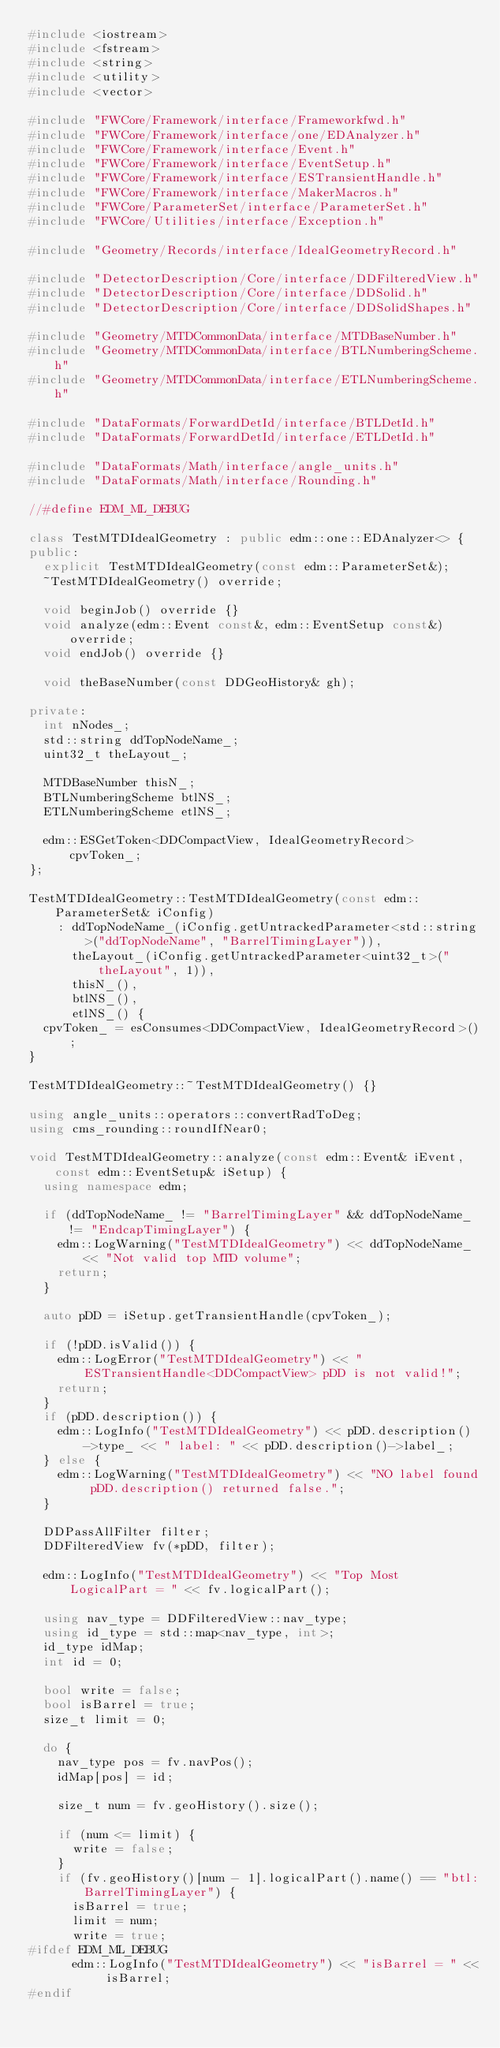<code> <loc_0><loc_0><loc_500><loc_500><_C++_>#include <iostream>
#include <fstream>
#include <string>
#include <utility>
#include <vector>

#include "FWCore/Framework/interface/Frameworkfwd.h"
#include "FWCore/Framework/interface/one/EDAnalyzer.h"
#include "FWCore/Framework/interface/Event.h"
#include "FWCore/Framework/interface/EventSetup.h"
#include "FWCore/Framework/interface/ESTransientHandle.h"
#include "FWCore/Framework/interface/MakerMacros.h"
#include "FWCore/ParameterSet/interface/ParameterSet.h"
#include "FWCore/Utilities/interface/Exception.h"

#include "Geometry/Records/interface/IdealGeometryRecord.h"

#include "DetectorDescription/Core/interface/DDFilteredView.h"
#include "DetectorDescription/Core/interface/DDSolid.h"
#include "DetectorDescription/Core/interface/DDSolidShapes.h"

#include "Geometry/MTDCommonData/interface/MTDBaseNumber.h"
#include "Geometry/MTDCommonData/interface/BTLNumberingScheme.h"
#include "Geometry/MTDCommonData/interface/ETLNumberingScheme.h"

#include "DataFormats/ForwardDetId/interface/BTLDetId.h"
#include "DataFormats/ForwardDetId/interface/ETLDetId.h"

#include "DataFormats/Math/interface/angle_units.h"
#include "DataFormats/Math/interface/Rounding.h"

//#define EDM_ML_DEBUG

class TestMTDIdealGeometry : public edm::one::EDAnalyzer<> {
public:
  explicit TestMTDIdealGeometry(const edm::ParameterSet&);
  ~TestMTDIdealGeometry() override;

  void beginJob() override {}
  void analyze(edm::Event const&, edm::EventSetup const&) override;
  void endJob() override {}

  void theBaseNumber(const DDGeoHistory& gh);

private:
  int nNodes_;
  std::string ddTopNodeName_;
  uint32_t theLayout_;

  MTDBaseNumber thisN_;
  BTLNumberingScheme btlNS_;
  ETLNumberingScheme etlNS_;

  edm::ESGetToken<DDCompactView, IdealGeometryRecord> cpvToken_;
};

TestMTDIdealGeometry::TestMTDIdealGeometry(const edm::ParameterSet& iConfig)
    : ddTopNodeName_(iConfig.getUntrackedParameter<std::string>("ddTopNodeName", "BarrelTimingLayer")),
      theLayout_(iConfig.getUntrackedParameter<uint32_t>("theLayout", 1)),
      thisN_(),
      btlNS_(),
      etlNS_() {
  cpvToken_ = esConsumes<DDCompactView, IdealGeometryRecord>();
}

TestMTDIdealGeometry::~TestMTDIdealGeometry() {}

using angle_units::operators::convertRadToDeg;
using cms_rounding::roundIfNear0;

void TestMTDIdealGeometry::analyze(const edm::Event& iEvent, const edm::EventSetup& iSetup) {
  using namespace edm;

  if (ddTopNodeName_ != "BarrelTimingLayer" && ddTopNodeName_ != "EndcapTimingLayer") {
    edm::LogWarning("TestMTDIdealGeometry") << ddTopNodeName_ << "Not valid top MTD volume";
    return;
  }

  auto pDD = iSetup.getTransientHandle(cpvToken_);

  if (!pDD.isValid()) {
    edm::LogError("TestMTDIdealGeometry") << "ESTransientHandle<DDCompactView> pDD is not valid!";
    return;
  }
  if (pDD.description()) {
    edm::LogInfo("TestMTDIdealGeometry") << pDD.description()->type_ << " label: " << pDD.description()->label_;
  } else {
    edm::LogWarning("TestMTDIdealGeometry") << "NO label found pDD.description() returned false.";
  }

  DDPassAllFilter filter;
  DDFilteredView fv(*pDD, filter);

  edm::LogInfo("TestMTDIdealGeometry") << "Top Most LogicalPart = " << fv.logicalPart();

  using nav_type = DDFilteredView::nav_type;
  using id_type = std::map<nav_type, int>;
  id_type idMap;
  int id = 0;

  bool write = false;
  bool isBarrel = true;
  size_t limit = 0;

  do {
    nav_type pos = fv.navPos();
    idMap[pos] = id;

    size_t num = fv.geoHistory().size();

    if (num <= limit) {
      write = false;
    }
    if (fv.geoHistory()[num - 1].logicalPart().name() == "btl:BarrelTimingLayer") {
      isBarrel = true;
      limit = num;
      write = true;
#ifdef EDM_ML_DEBUG
      edm::LogInfo("TestMTDIdealGeometry") << "isBarrel = " << isBarrel;
#endif</code> 